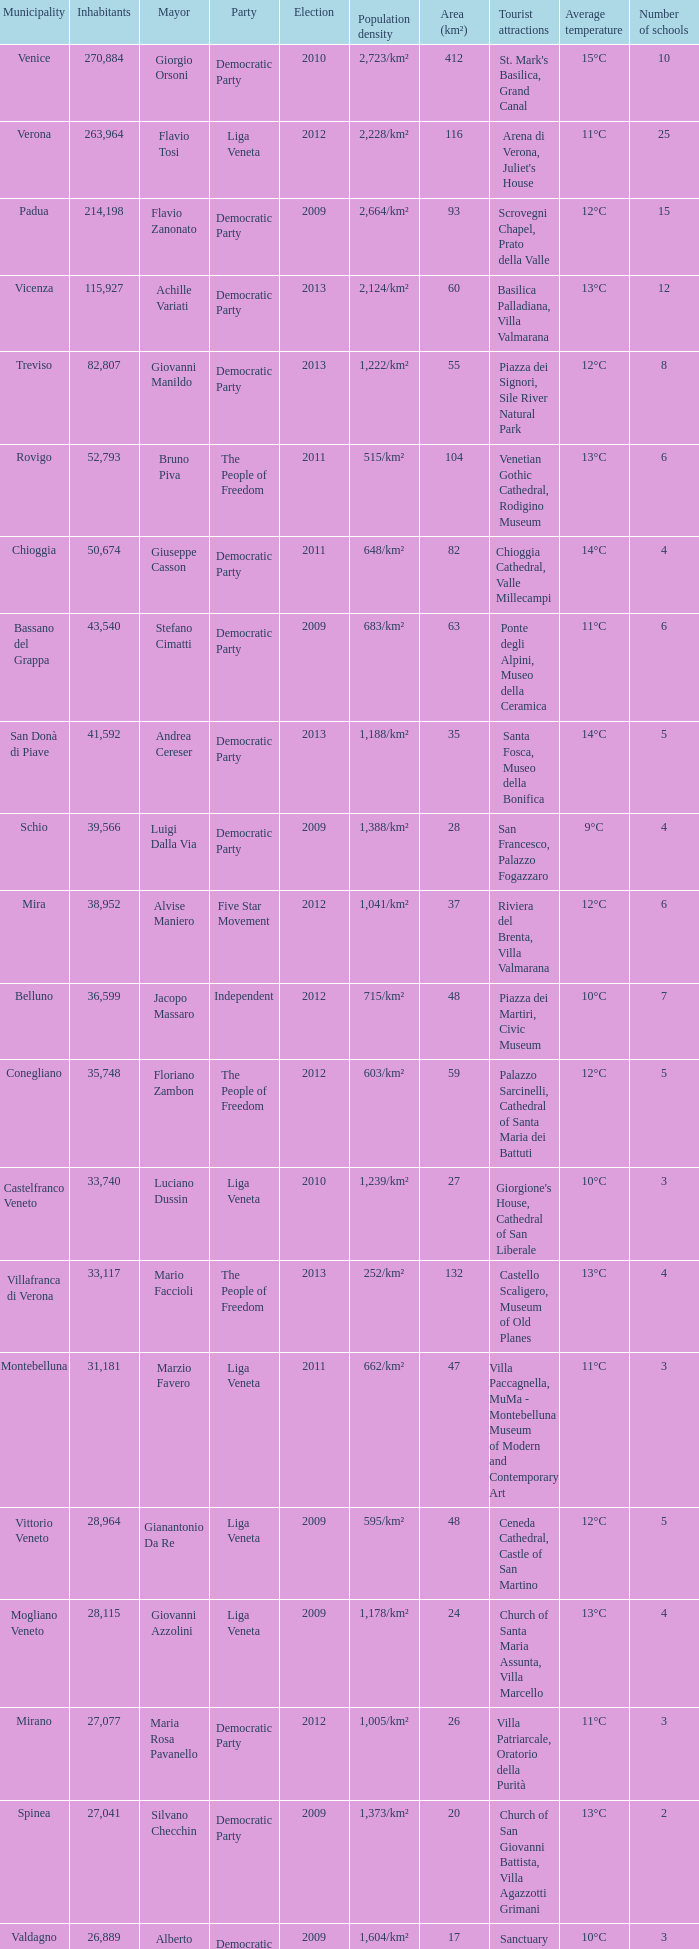How many elections had more than 36,599 inhabitants when Mayor was giovanni manildo? 1.0. 